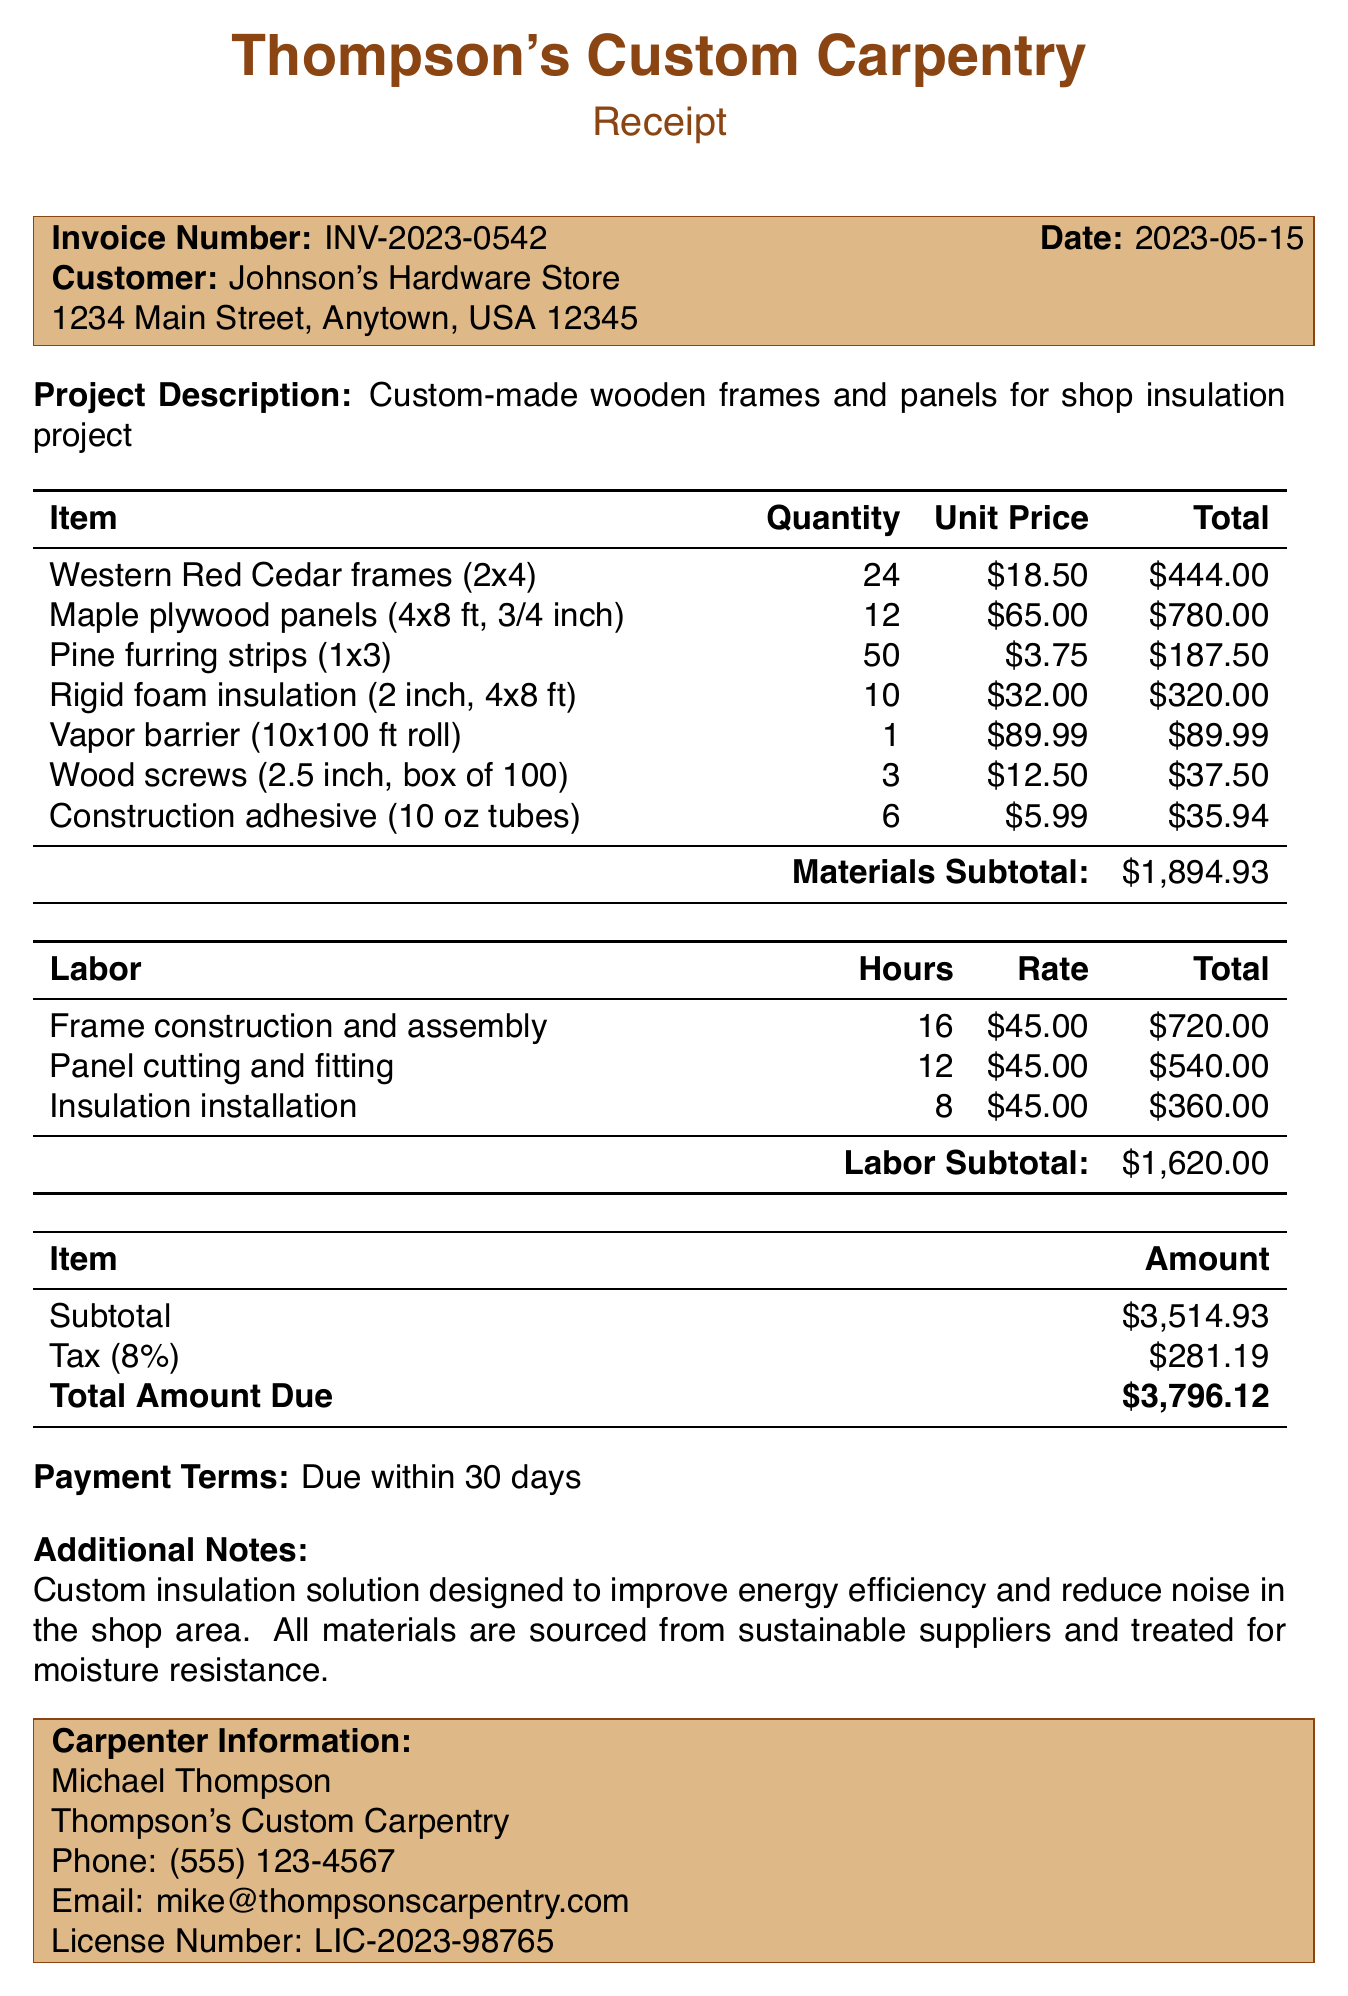What is the invoice number? The invoice number is a unique identifier for this transaction, found in the document.
Answer: INV-2023-0542 What is the total amount due? The total amount due is the final payment required for the project, which is shown in the document.
Answer: $3,796.12 How many Maple plywood panels were ordered? The quantity of Maple plywood panels is listed in the line items of the invoice.
Answer: 12 What is the tax rate applied? The document specifies the percentage used to calculate the tax on the subtotal.
Answer: 8% What is the description of the project? The project description can be found at the beginning of the invoice, summarizing the work done.
Answer: Custom-made wooden frames and panels for shop insulation project How much was charged for labor in total? The labor section of the invoice lists the total charge for labor services rendered for the project.
Answer: $1,620.00 What is the customer's address? The address of the customer can be found near the top of the document.
Answer: 1234 Main Street, Anytown, USA 12345 Who is the carpenter responsible for this project? The carpenter's information is listed at the end of the invoice, identifying who completed the work.
Answer: Michael Thompson How many hours were dedicated to insulation installation? The labor details include the hours spent on insulation installation as part of the total labor effort.
Answer: 8 